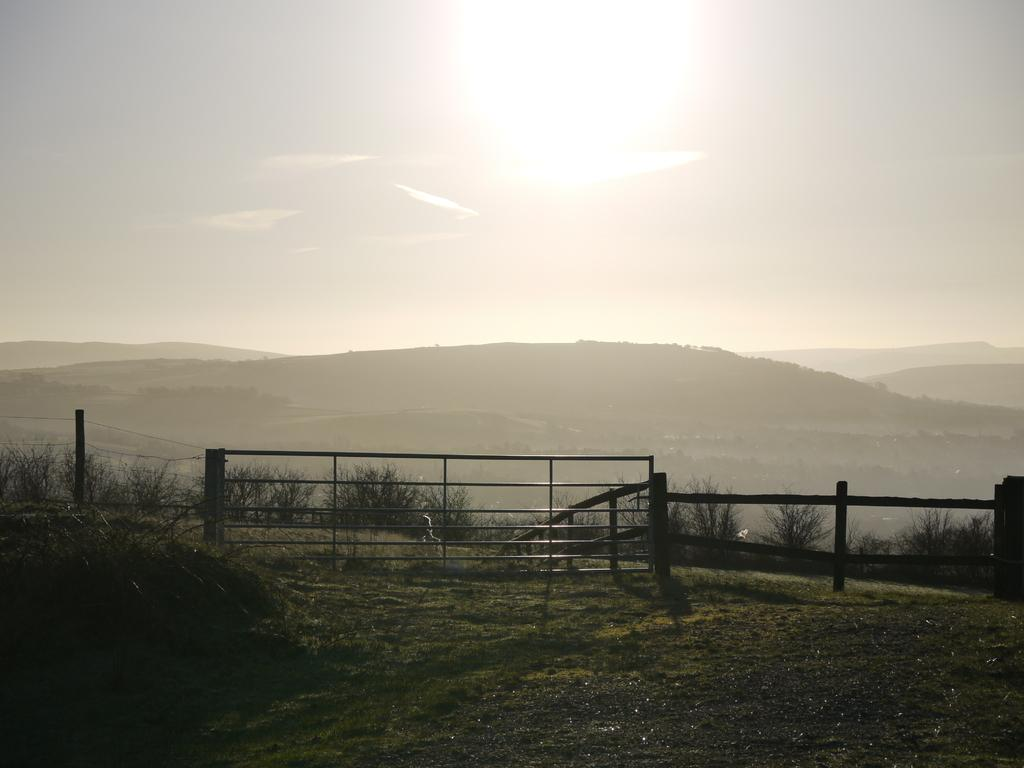What is present in the image that separates or encloses an area? There is a fence in the image. What is the person in the image doing? A person is walking on the ground in the image. What type of vegetation can be seen in the background of the image? There are trees in the background of the image. What else is visible in the background of the image? There is grass and the sky visible in the background of the image. Is there a volcano visible in the image? No, there is no volcano present in the image. What type of tin is being used by the person walking in the image? There is no tin mentioned or visible in the image. 